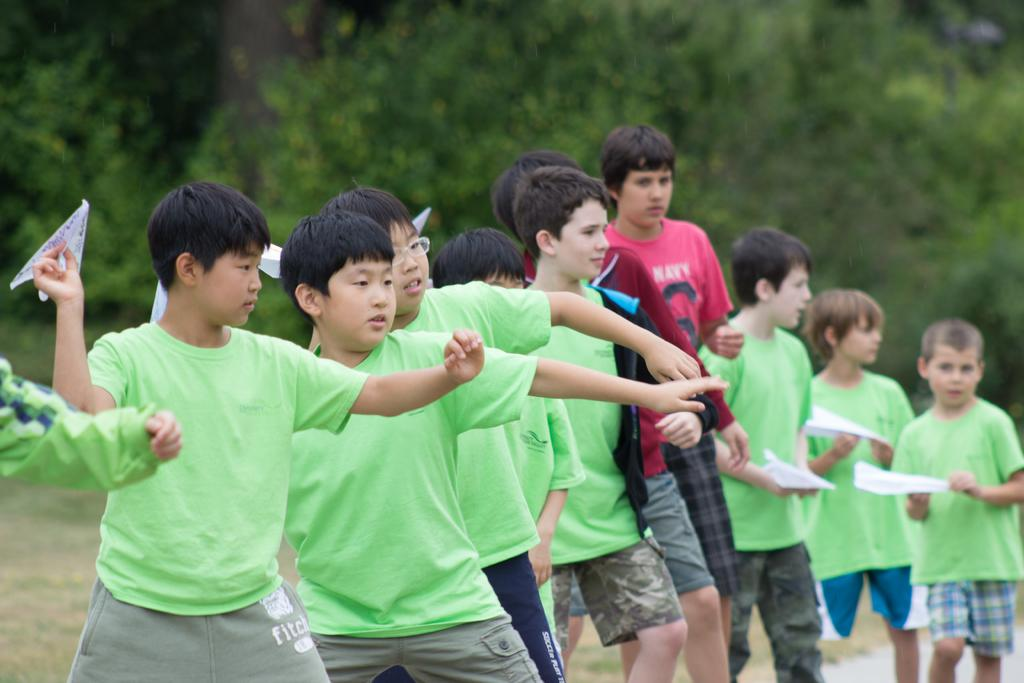What can be seen in the foreground of the image? There are boys visible in the foreground of the image. What are some of the boys holding in the image? Some of the boys are holding paper aeroplanes. What type of natural scenery is visible in the background of the image? There are trees in the background of the image. Can you tell me how to use the zipper on the boys' clothing in the image? There is no mention of zippers or clothing in the image; it only shows boys holding paper aeroplanes and trees in the background. 